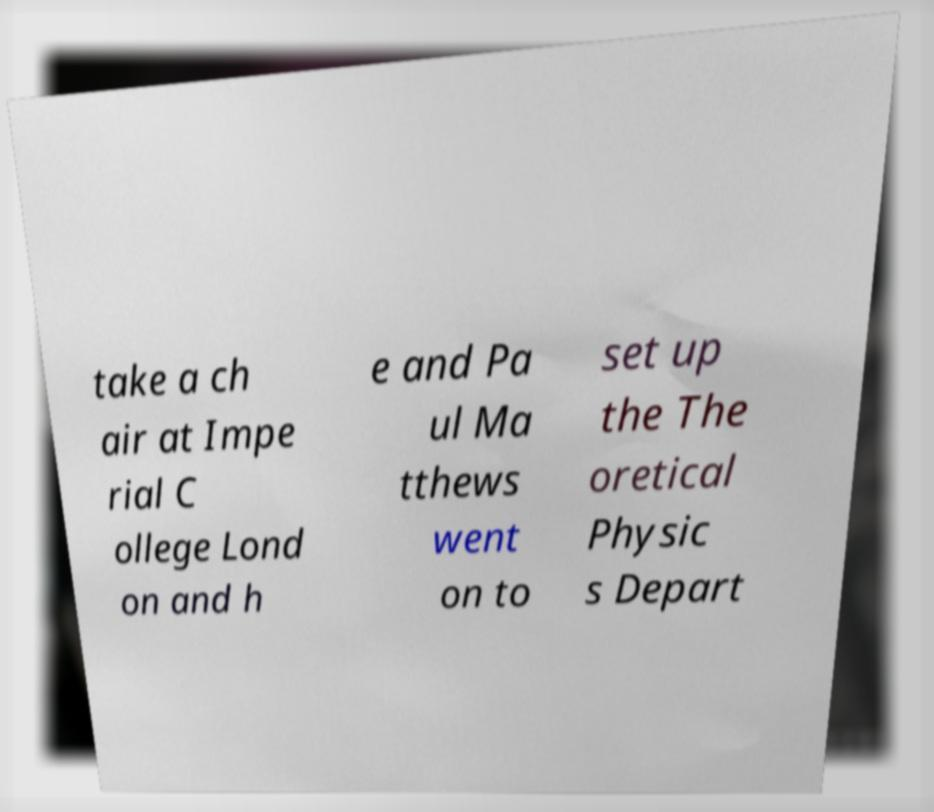Can you read and provide the text displayed in the image?This photo seems to have some interesting text. Can you extract and type it out for me? take a ch air at Impe rial C ollege Lond on and h e and Pa ul Ma tthews went on to set up the The oretical Physic s Depart 